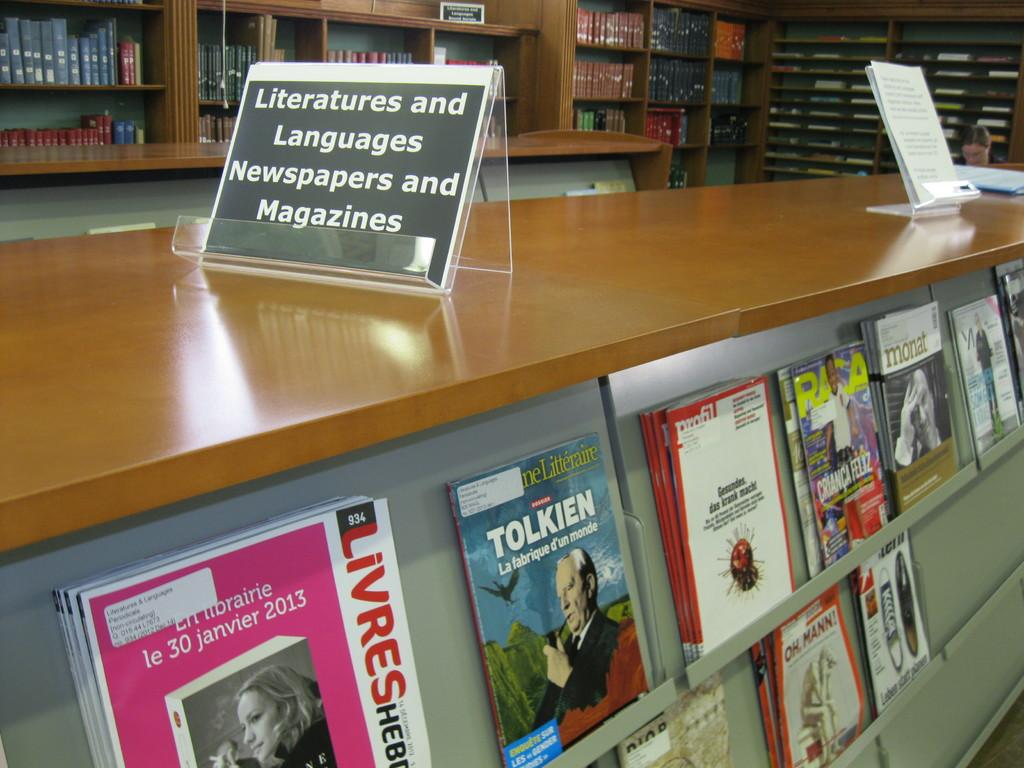What type of reading material is visible in the image? There is a group of magazines in the image. Where are the magazines located in relation to other objects? The magazines are placed beside a table. What can be seen in the background of the image? There is a bookshelf in the background of the image. Can you see any goldfish swimming in the magazines in the image? There are no goldfish present in the image, as it features a group of magazines and a bookshelf. 